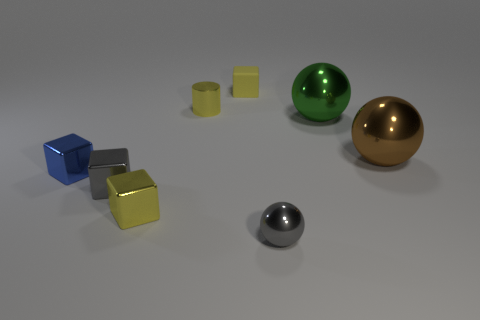How many big brown things are behind the ball that is on the left side of the large green metallic object that is behind the gray metal sphere?
Your response must be concise. 1. Does the yellow shiny block have the same size as the green shiny object on the right side of the tiny metal ball?
Provide a succinct answer. No. What number of tiny gray cubes are there?
Offer a very short reply. 1. Does the metallic ball behind the brown shiny sphere have the same size as the sphere that is in front of the brown metal ball?
Make the answer very short. No. What is the color of the other tiny object that is the same shape as the green metal object?
Ensure brevity in your answer.  Gray. Is the tiny yellow rubber thing the same shape as the big brown metal thing?
Provide a succinct answer. No. There is another blue object that is the same shape as the rubber object; what is its size?
Offer a very short reply. Small. What number of brown balls have the same material as the tiny blue thing?
Offer a terse response. 1. How many things are either big balls or tiny balls?
Your answer should be compact. 3. There is a yellow object in front of the large brown metallic object; are there any yellow blocks that are behind it?
Your answer should be compact. Yes. 